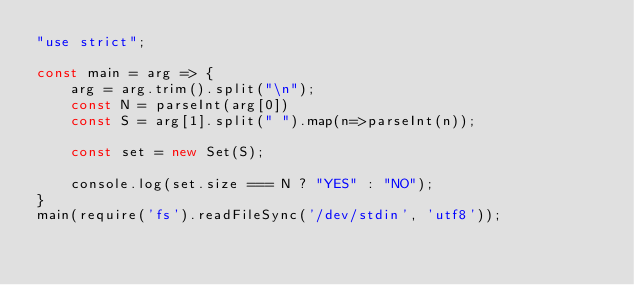Convert code to text. <code><loc_0><loc_0><loc_500><loc_500><_JavaScript_>"use strict";
    
const main = arg => {
    arg = arg.trim().split("\n");
    const N = parseInt(arg[0])
    const S = arg[1].split(" ").map(n=>parseInt(n));
    
    const set = new Set(S);
    
    console.log(set.size === N ? "YES" : "NO");
}
main(require('fs').readFileSync('/dev/stdin', 'utf8'));</code> 